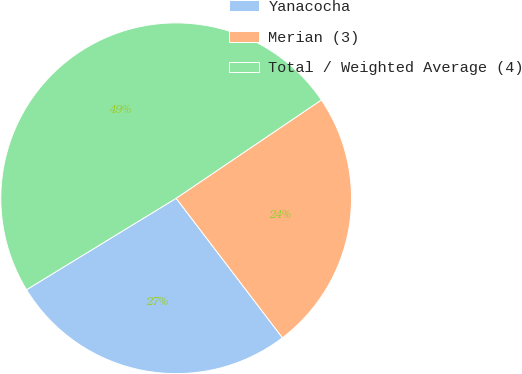<chart> <loc_0><loc_0><loc_500><loc_500><pie_chart><fcel>Yanacocha<fcel>Merian (3)<fcel>Total / Weighted Average (4)<nl><fcel>26.63%<fcel>24.11%<fcel>49.26%<nl></chart> 